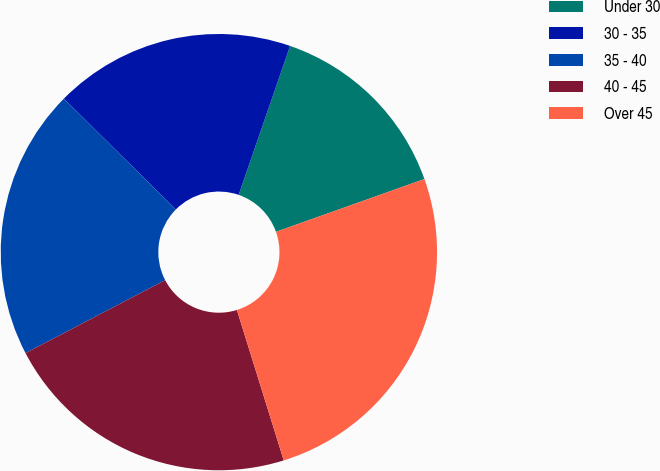<chart> <loc_0><loc_0><loc_500><loc_500><pie_chart><fcel>Under 30<fcel>30 - 35<fcel>35 - 40<fcel>40 - 45<fcel>Over 45<nl><fcel>14.27%<fcel>17.87%<fcel>20.08%<fcel>22.14%<fcel>25.63%<nl></chart> 